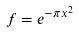Convert formula to latex. <formula><loc_0><loc_0><loc_500><loc_500>f = e ^ { - \pi x ^ { 2 } }</formula> 